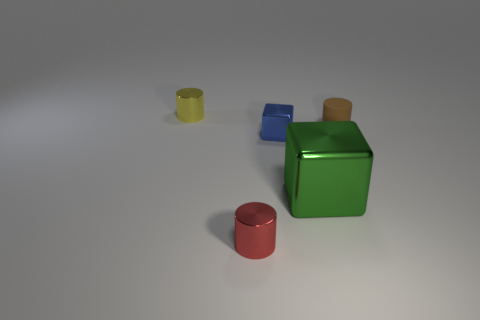Subtract all red metallic cylinders. How many cylinders are left? 2 Subtract all blue cubes. How many cubes are left? 1 Subtract all cylinders. How many objects are left? 2 Add 1 yellow metal things. How many objects exist? 6 Subtract all gray cubes. Subtract all blue spheres. How many cubes are left? 2 Subtract all gray blocks. How many green cylinders are left? 0 Subtract all small yellow cylinders. Subtract all blocks. How many objects are left? 2 Add 4 small red metallic objects. How many small red metallic objects are left? 5 Add 3 big blocks. How many big blocks exist? 4 Subtract 0 cyan cylinders. How many objects are left? 5 